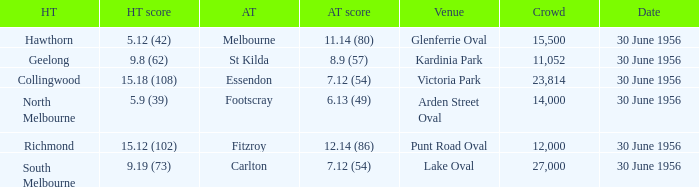What is the home team at Victoria Park with an Away team score of 7.12 (54) and more than 12,000 people? Collingwood. 